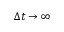<formula> <loc_0><loc_0><loc_500><loc_500>\Delta t \to \infty</formula> 